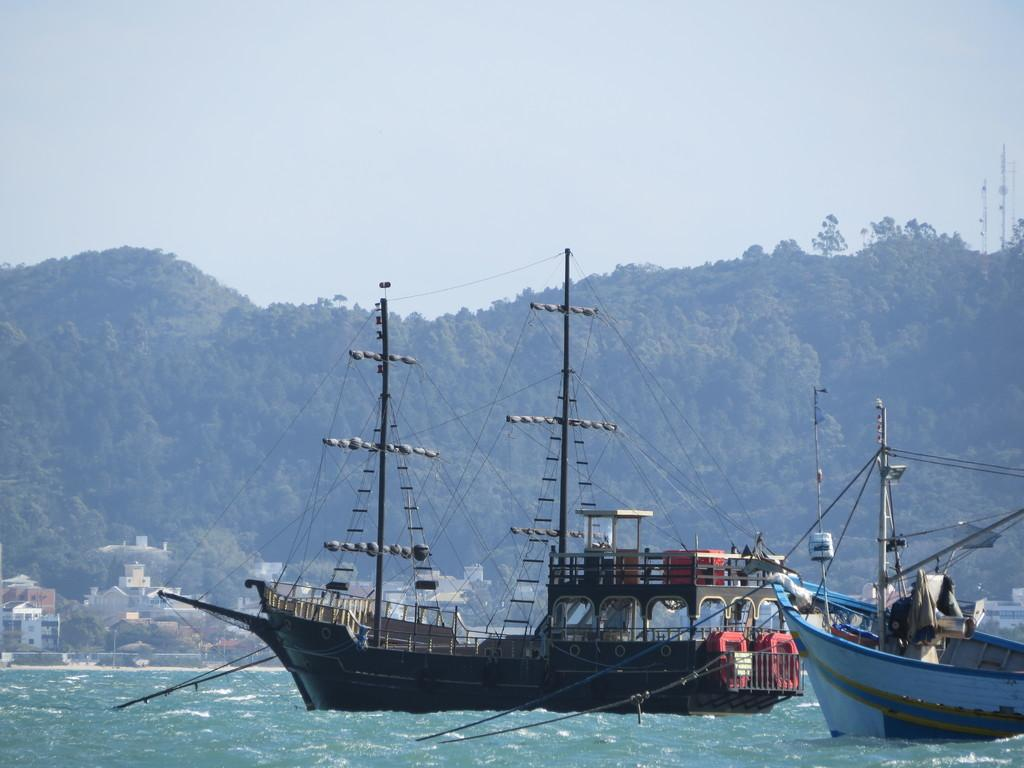What is the main subject of the image? The main subject of the image is ships on the water. What else can be seen in the image besides the ships? There are poles and objects, trees, buildings, towers, and clouds visible in the image. Can you describe the background of the image? The background of the image includes trees, buildings, towers, and clouds. How many clocks are hanging from the towers in the image? There are no clocks visible in the image; only ships, poles, objects, trees, buildings, towers, and clouds can be seen. Is there a seat on the ship for passengers to sit? The image does not provide enough detail to determine if there is a seat on the ship for passengers to sit. Can you see a match being lit in the image? There is no match or any indication of fire in the image. 